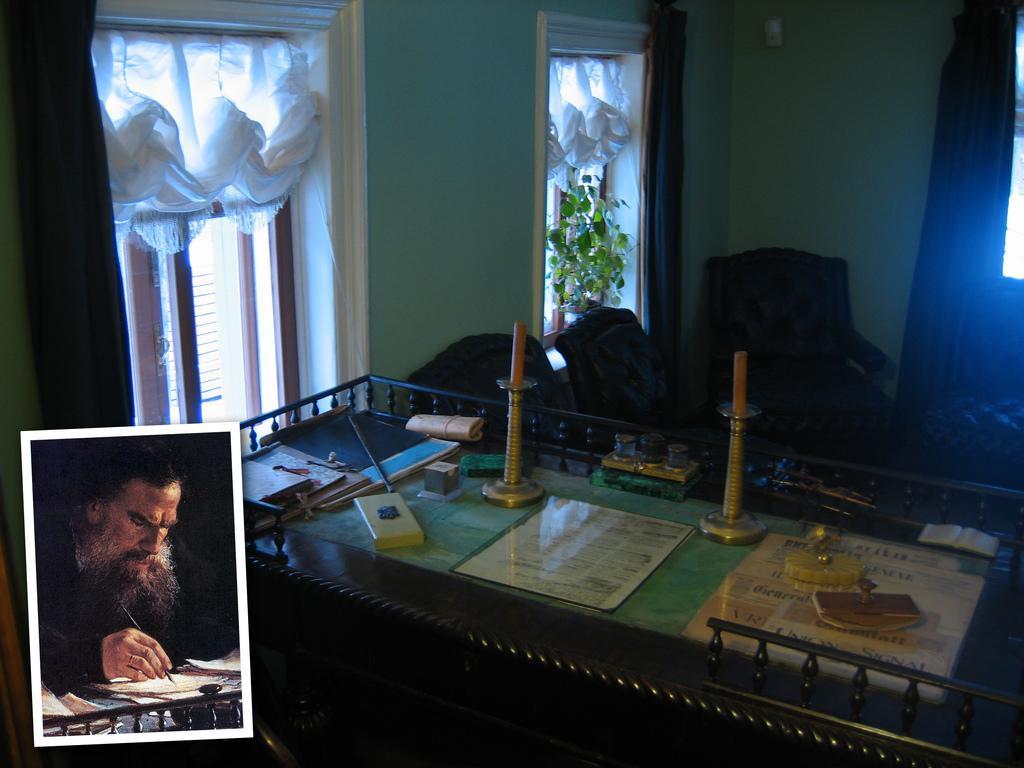Can you describe this image briefly? In this image, we can see a table. On top of that, we can see few objects, stands with candle. Background we can see chairs, walls, windows, curtains and house plant. On the left side bottom of the image, we can see a photograph. In that photograph, we can see a person is holding an object. 